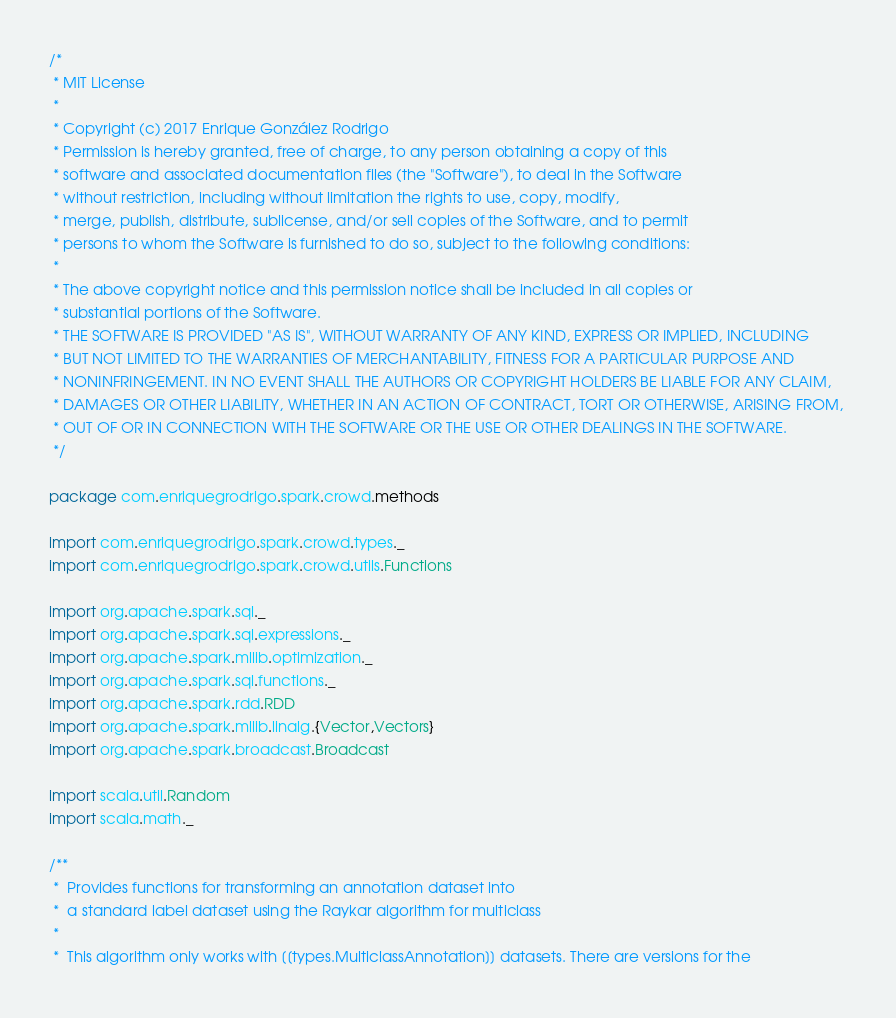Convert code to text. <code><loc_0><loc_0><loc_500><loc_500><_Scala_>/*
 * MIT License 
 *
 * Copyright (c) 2017 Enrique González Rodrigo 
 * Permission is hereby granted, free of charge, to any person obtaining a copy of this 
 * software and associated documentation files (the "Software"), to deal in the Software 
 * without restriction, including without limitation the rights to use, copy, modify, 
 * merge, publish, distribute, sublicense, and/or sell copies of the Software, and to permit 
 * persons to whom the Software is furnished to do so, subject to the following conditions: 
 *
 * The above copyright notice and this permission notice shall be included in all copies or 
 * substantial portions of the Software.  
 * THE SOFTWARE IS PROVIDED "AS IS", WITHOUT WARRANTY OF ANY KIND, EXPRESS OR IMPLIED, INCLUDING 
 * BUT NOT LIMITED TO THE WARRANTIES OF MERCHANTABILITY, FITNESS FOR A PARTICULAR PURPOSE AND 
 * NONINFRINGEMENT. IN NO EVENT SHALL THE AUTHORS OR COPYRIGHT HOLDERS BE LIABLE FOR ANY CLAIM, 
 * DAMAGES OR OTHER LIABILITY, WHETHER IN AN ACTION OF CONTRACT, TORT OR OTHERWISE, ARISING FROM, 
 * OUT OF OR IN CONNECTION WITH THE SOFTWARE OR THE USE OR OTHER DEALINGS IN THE SOFTWARE.
 */

package com.enriquegrodrigo.spark.crowd.methods

import com.enriquegrodrigo.spark.crowd.types._
import com.enriquegrodrigo.spark.crowd.utils.Functions

import org.apache.spark.sql._
import org.apache.spark.sql.expressions._
import org.apache.spark.mllib.optimization._
import org.apache.spark.sql.functions._
import org.apache.spark.rdd.RDD
import org.apache.spark.mllib.linalg.{Vector,Vectors}
import org.apache.spark.broadcast.Broadcast

import scala.util.Random
import scala.math._

/**
 *  Provides functions for transforming an annotation dataset into 
 *  a standard label dataset using the Raykar algorithm for multiclass
 *
 *  This algorithm only works with [[types.MulticlassAnnotation]] datasets. There are versions for the </code> 